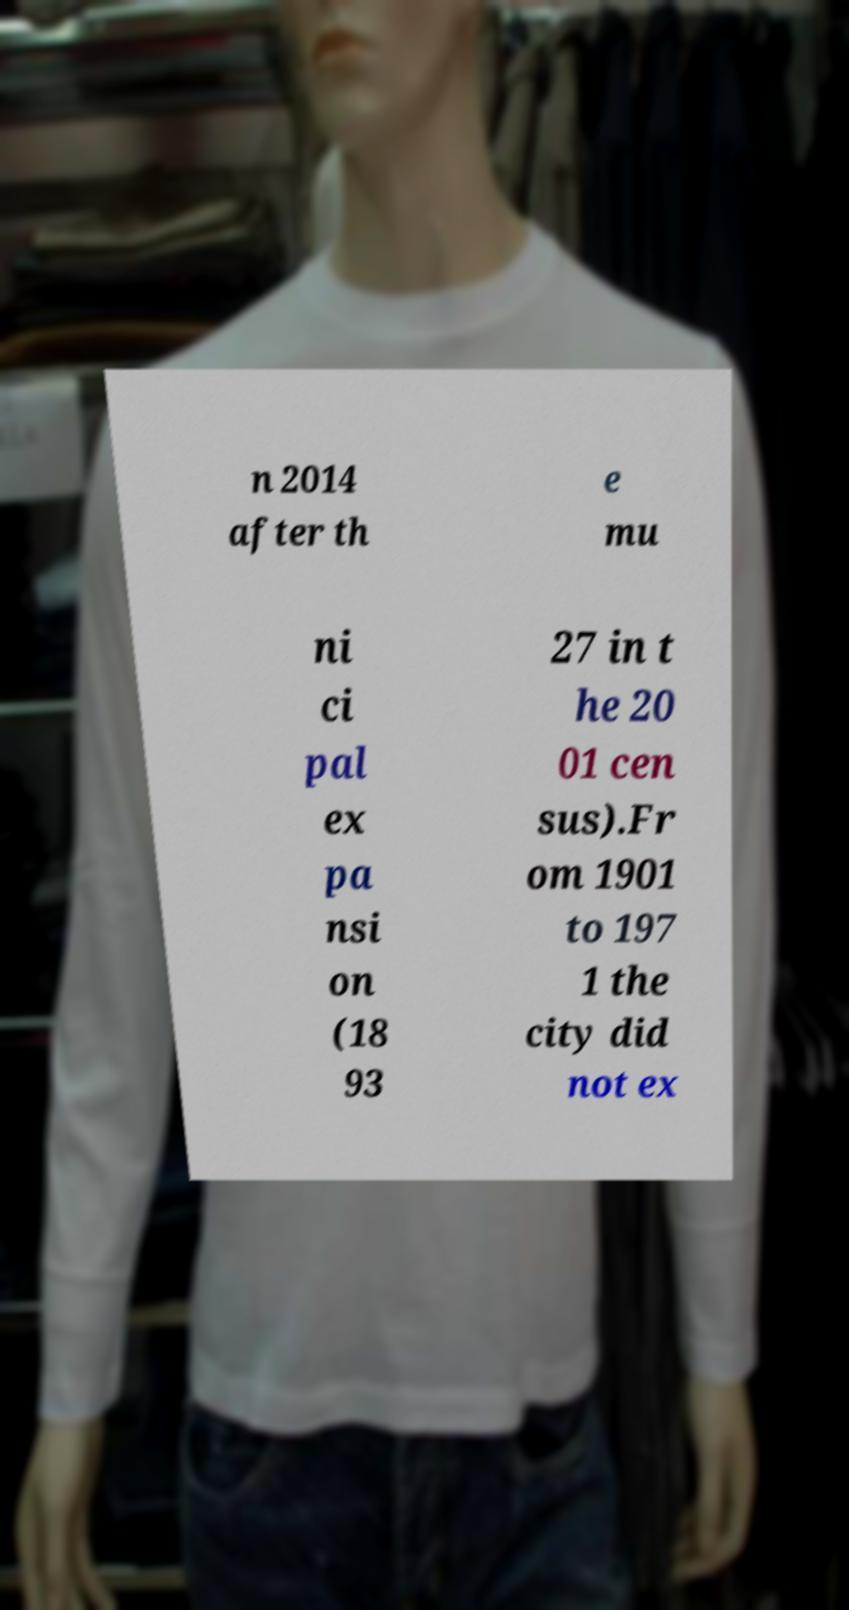What messages or text are displayed in this image? I need them in a readable, typed format. n 2014 after th e mu ni ci pal ex pa nsi on (18 93 27 in t he 20 01 cen sus).Fr om 1901 to 197 1 the city did not ex 